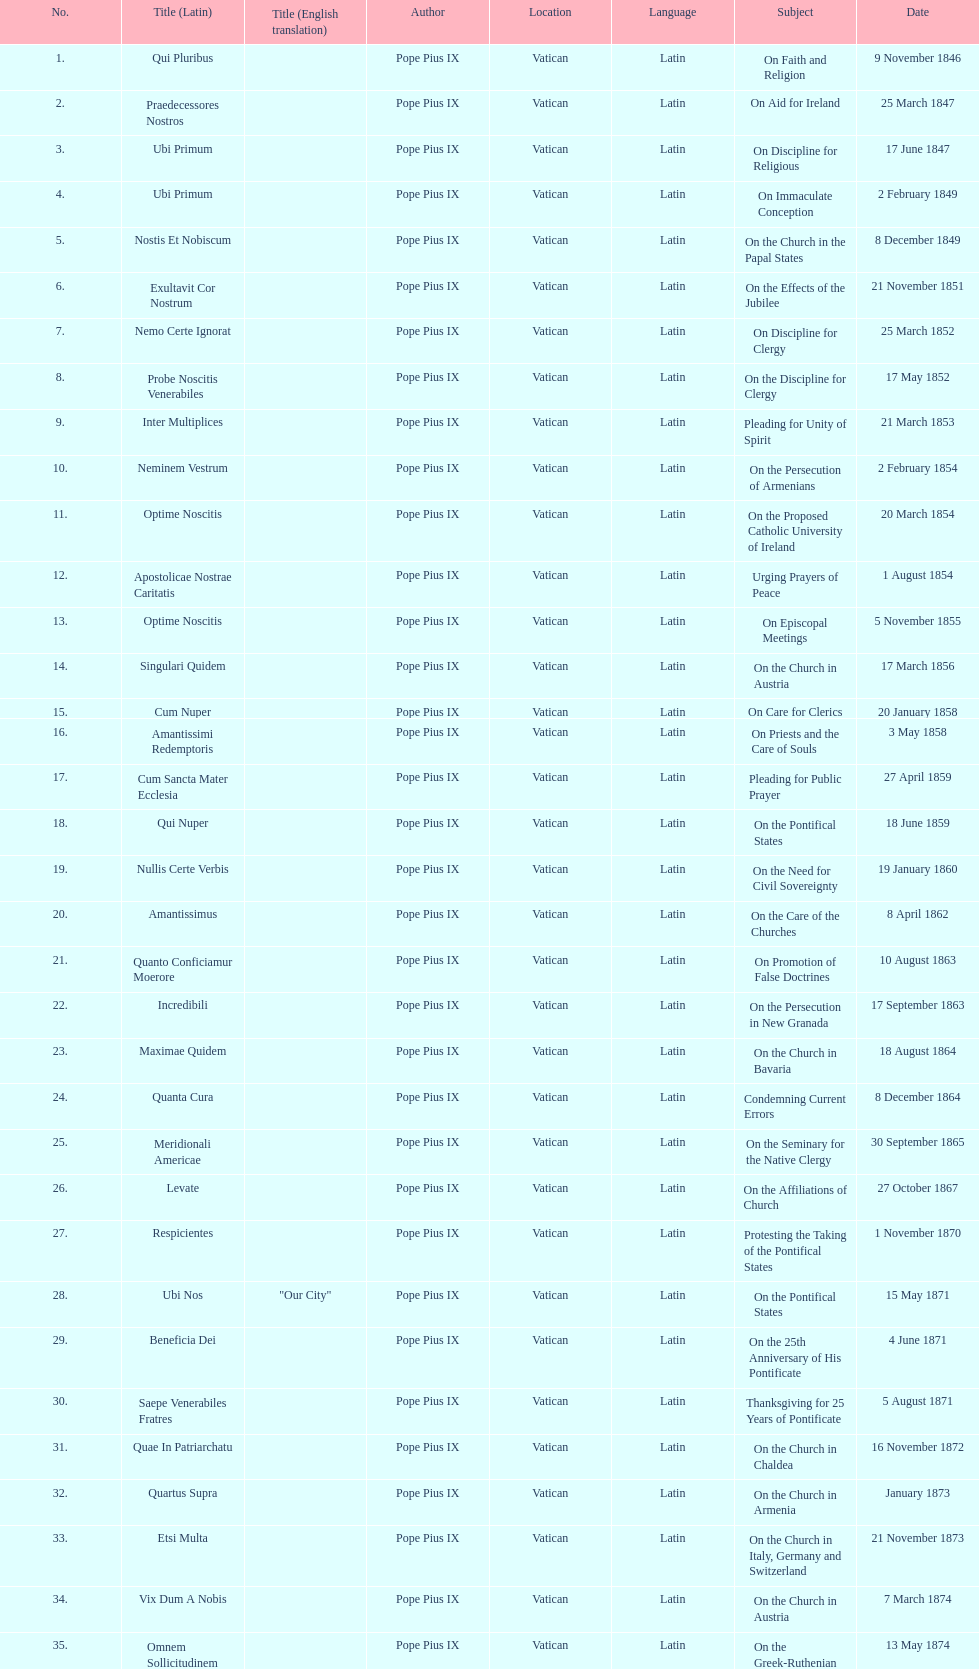In the first 10 years of his reign, how many encyclicals did pope pius ix issue? 14. 